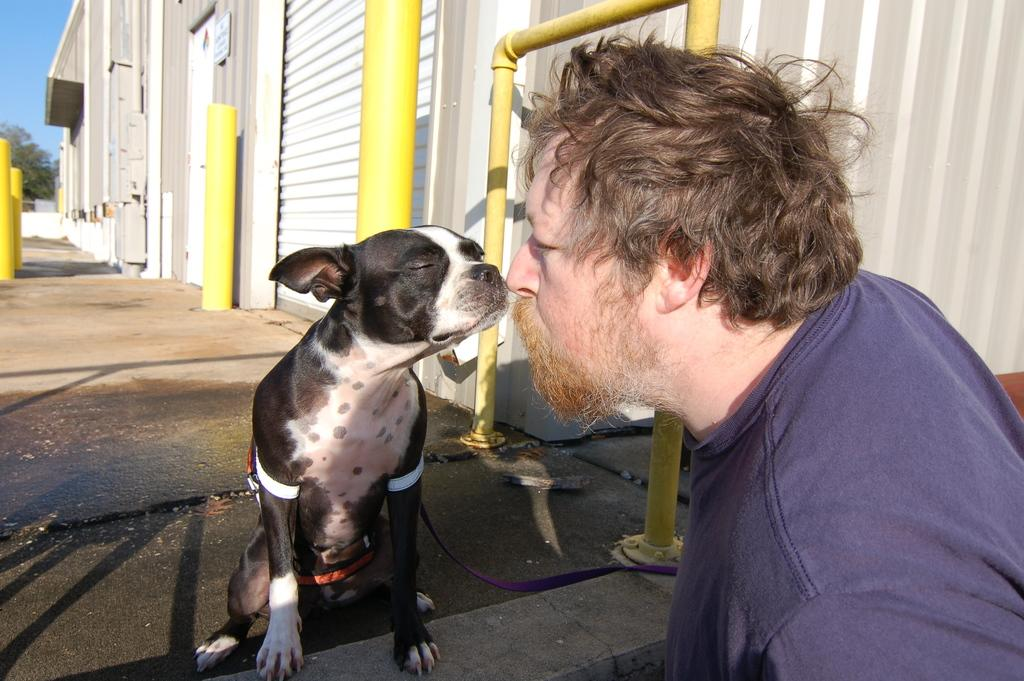Who is present in the image? There is a guy in the image. What is the guy doing in the image? The guy is facing a black dog in the image. Where is the dog located in the image? The dog is on the floor in the image. What can be seen in the background of the image? There are small buildings in the background of the image. What type of brass instrument is the guy playing in the image? There is no brass instrument present in the image; the guy is facing a black dog. 